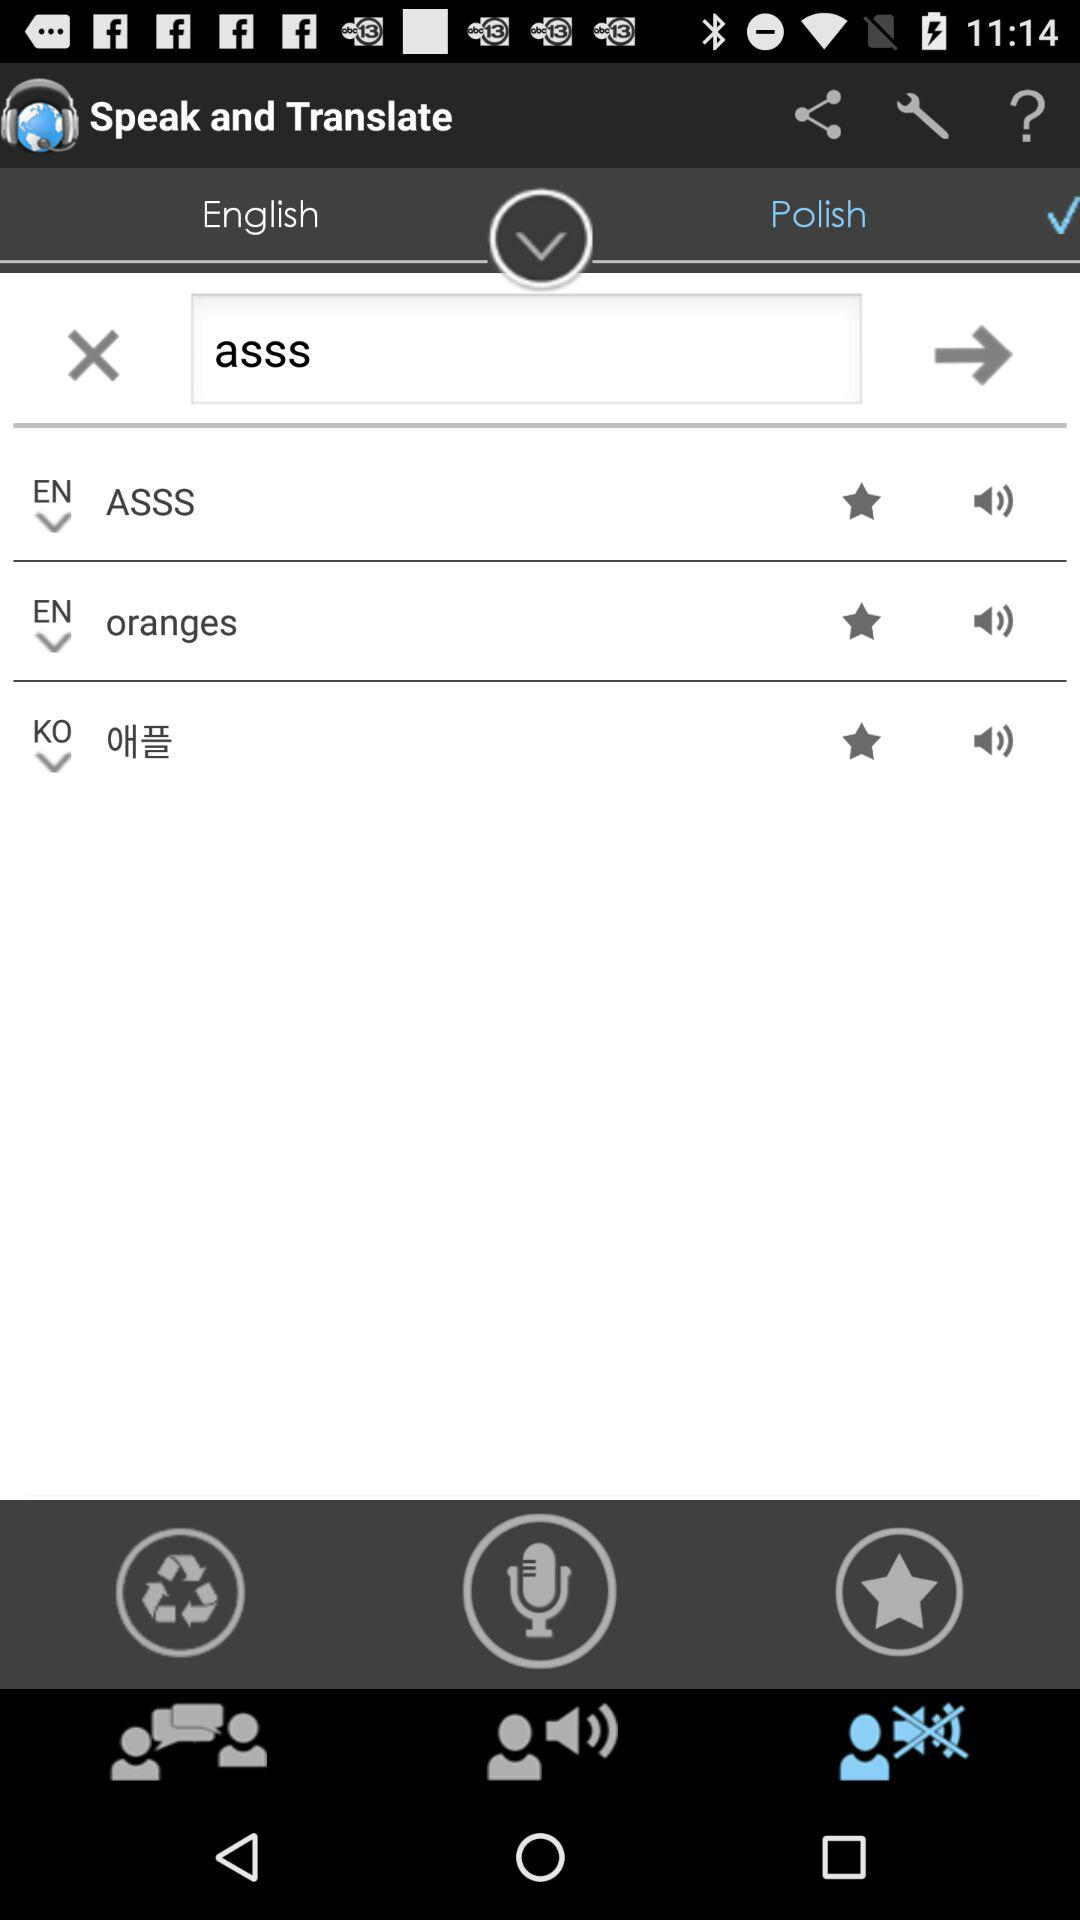What is the translation language? The translation language is Polish. 